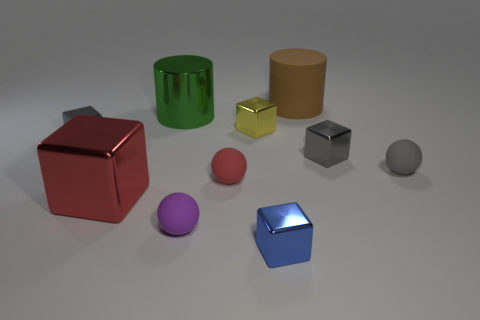What is the color of the big metal thing that is in front of the tiny gray metallic cube that is on the right side of the small gray block left of the big brown thing?
Provide a succinct answer. Red. Is the material of the large cylinder to the left of the blue object the same as the object behind the shiny cylinder?
Make the answer very short. No. What shape is the tiny gray thing that is left of the red shiny block?
Keep it short and to the point. Cube. What number of objects are either tiny gray balls or big objects that are to the left of the green metallic cylinder?
Ensure brevity in your answer.  2. Are the small purple ball and the blue block made of the same material?
Provide a succinct answer. No. Are there the same number of green metallic cylinders that are behind the big rubber thing and brown objects in front of the small blue shiny object?
Your answer should be very brief. Yes. How many tiny purple things are behind the small purple ball?
Offer a terse response. 0. How many objects are either cylinders or large matte objects?
Offer a very short reply. 2. How many gray objects have the same size as the green object?
Your response must be concise. 0. There is a small gray metallic object right of the tiny metallic block that is in front of the gray rubber object; what shape is it?
Offer a very short reply. Cube. 